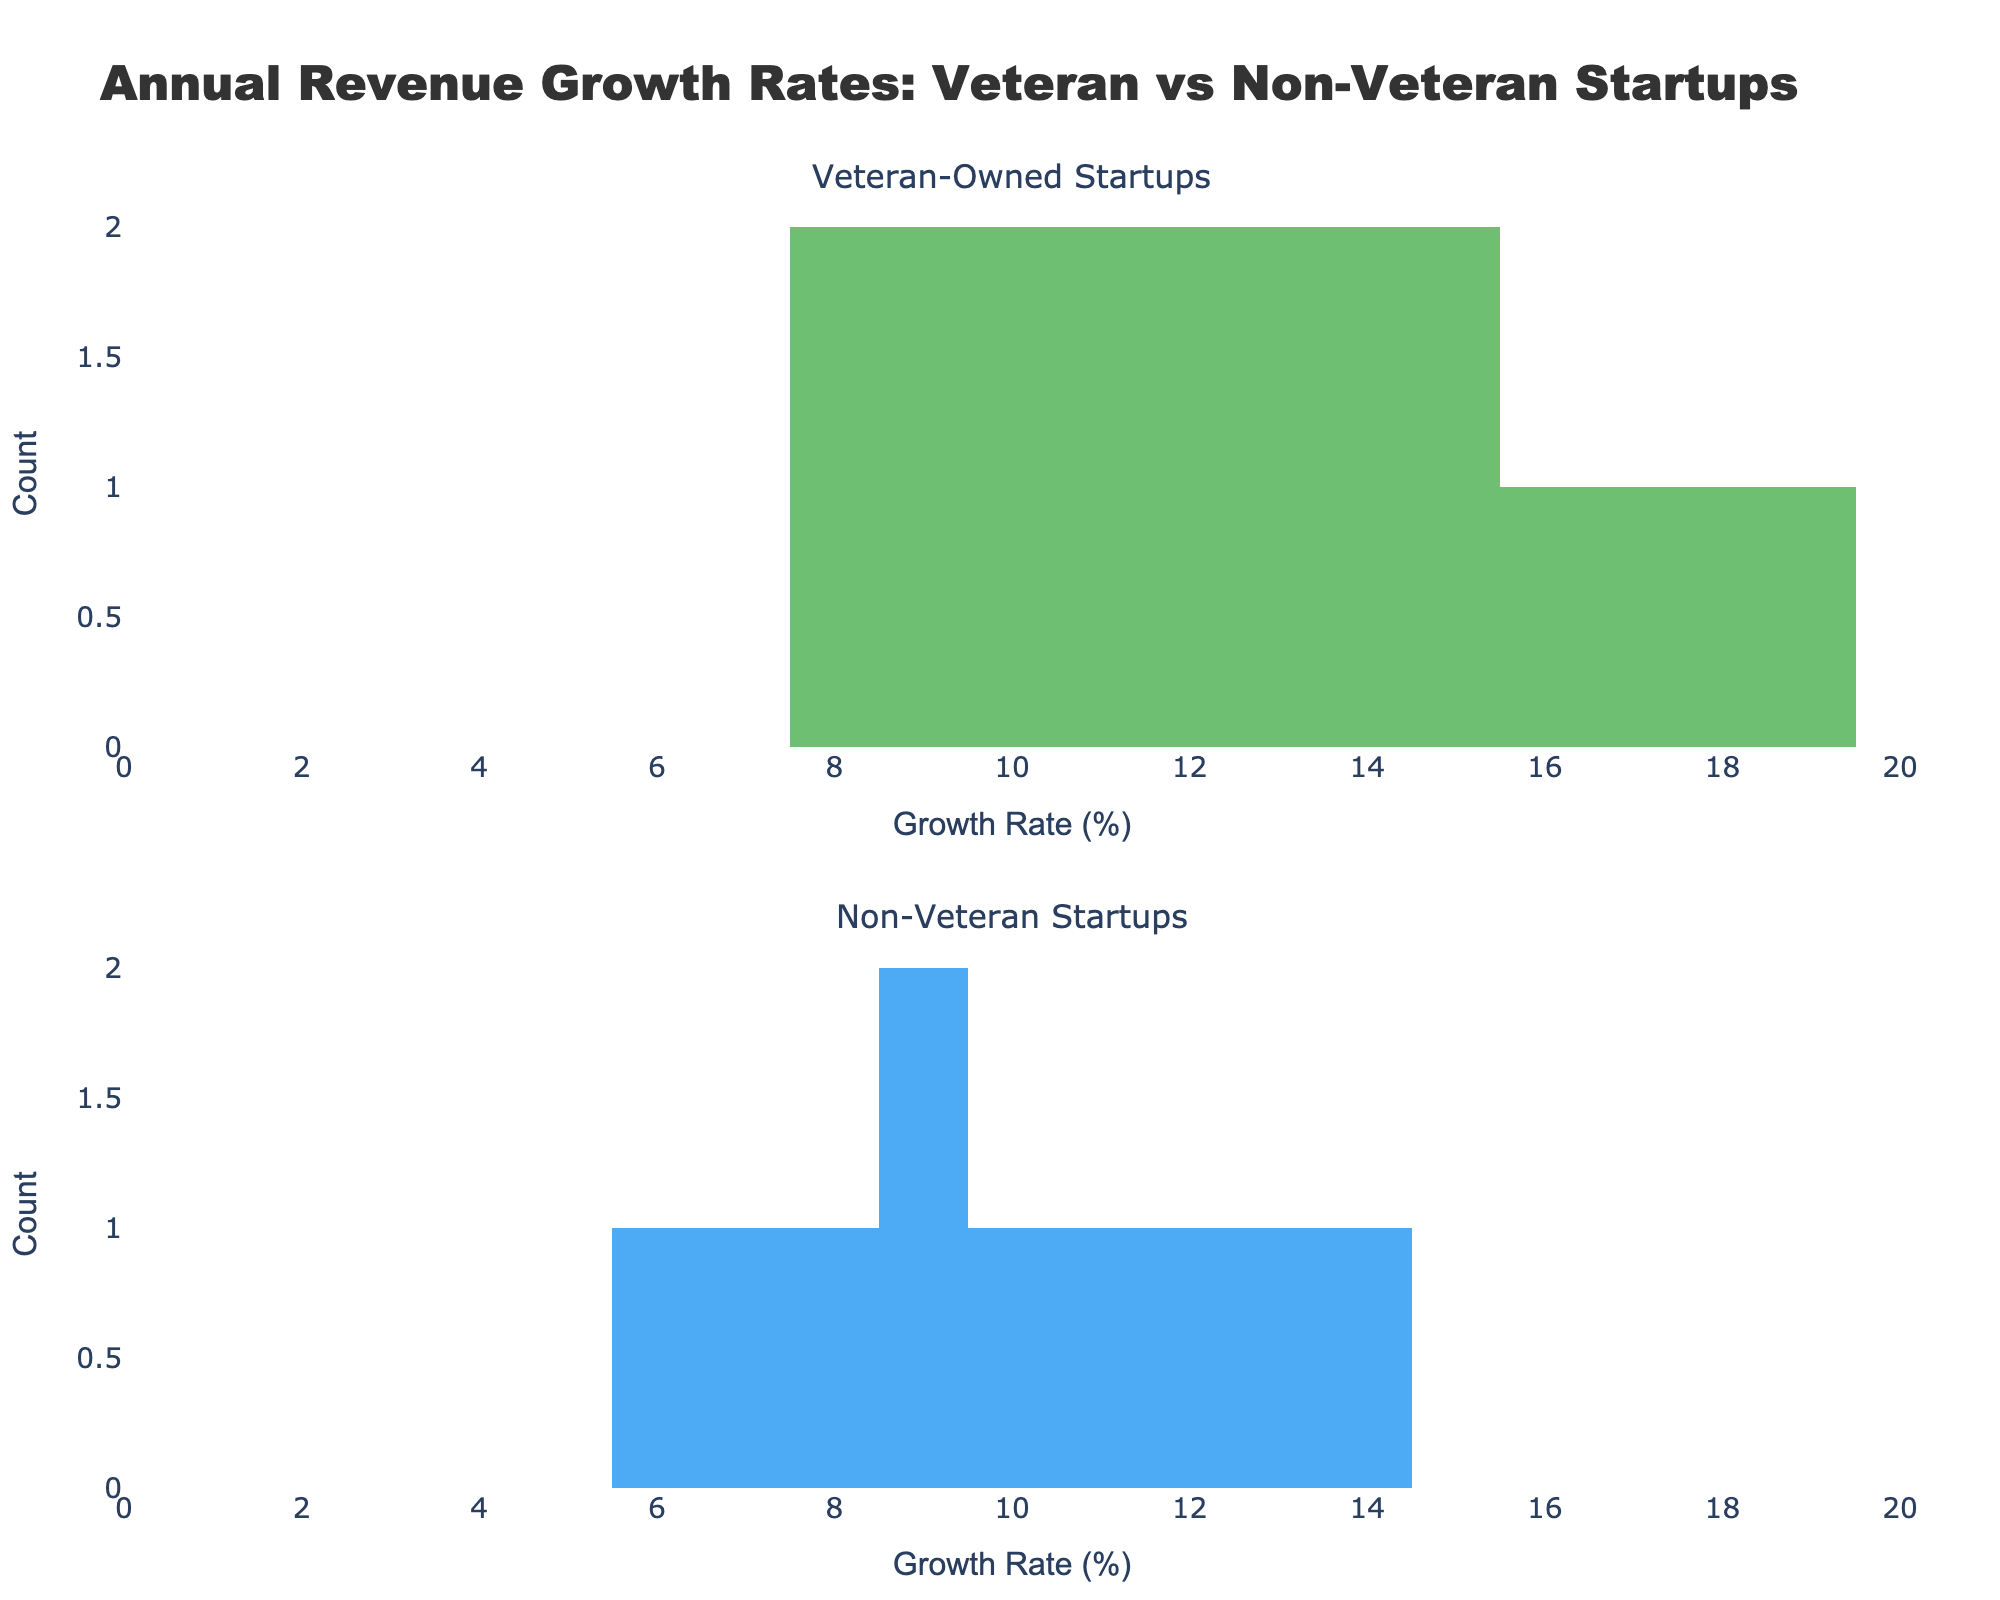what is the title of the figure? The title of the figure is prominently displayed at the top. It reads "Annual Revenue Growth Rates: Veteran vs Non-Veteran Startups".
Answer: Annual Revenue Growth Rates: Veteran vs Non-Veteran Startups What colors are used for the histograms representing veteran-owned startups and non-veteran startups? The colors used are green for veteran-owned startups and blue for non-veteran startups.
Answer: Green and Blue How many bins are used for the histograms? Each histogram is divided into 10 bins, which is visibly indicated by the markings on the x-axis.
Answer: 10 Which group has a higher peak count in their growth rate distribution? By comparing the heights of the bars in each histogram, the non-veteran startups have a higher peak count in their distribution.
Answer: Non-Veteran Startups What is the growth rate range displayed on the x-axis? The x-axis ranges from 0 to 20 percent growth rate, as indicated by the range and ticks on the axis.
Answer: 0 to 20 percent Which histogram shows more data points in the 10-12% growth rate interval? By observing the bars for the 10-12% interval, the histogram for veteran-owned startups has more data points in that interval.
Answer: Veteran-Owned Startups What's the average growth rate for veteran-owned startups? To find the average, sum the growth rates for veteran-owned startups (12+15+8+18+10+14+9+16+11+13=126) and divide by the number of data points (10). The average growth rate is 126/10 = 12.6%.
Answer: 12.6% Is there any overlap in the growth rate ranges that have data for both groups? Both histograms have data points in the growth rate range of 6 to 16 percent, indicating an overlap in this interval.
Answer: 6 to 16 percent Which group has the lowest recorded growth rate? The lowest recorded growth rate for non-veteran startups is 6%, while for veteran-owned startups it is 8%. Hence, non-veteran startups have the lower recorded growth rate.
Answer: Non-Veteran Startups How many categories of startups are represented in the figure? The figure has two categories: veteran-owned startups and non-veteran startups, as indicated by the subplot titles.
Answer: Two 